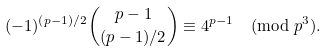Convert formula to latex. <formula><loc_0><loc_0><loc_500><loc_500>( - 1 ) ^ { ( p - 1 ) / 2 } \binom { p - 1 } { ( p - 1 ) / 2 } \equiv 4 ^ { p - 1 } \pmod { p ^ { 3 } } .</formula> 